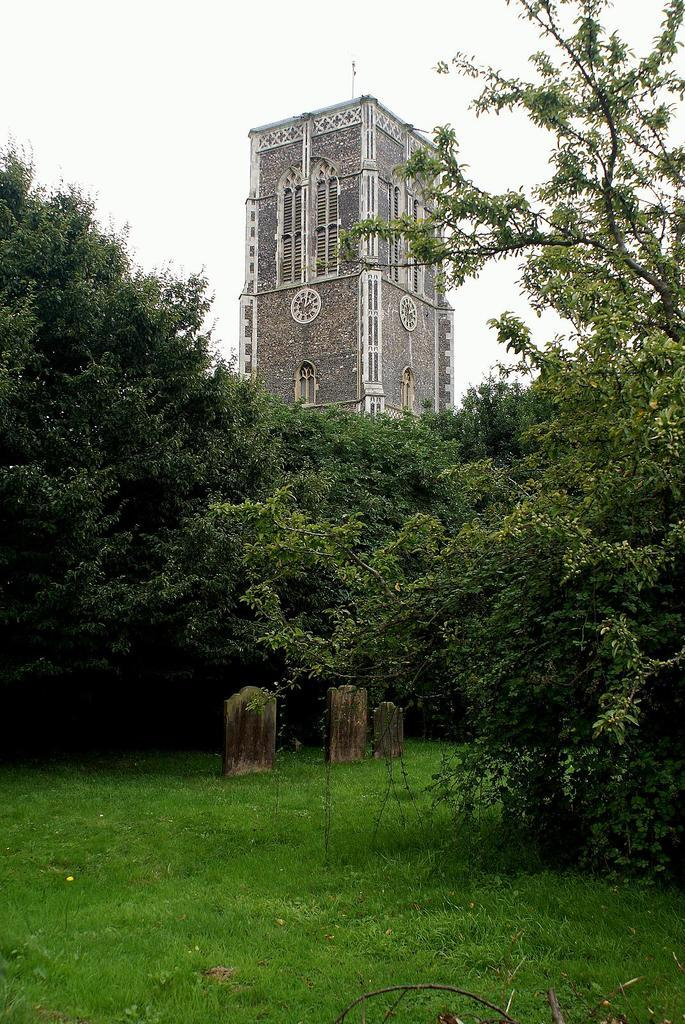What type of vegetation can be seen in the image? There is grass and trees in the image. What structures are visible in the background of the image? There is a building in the background of the image. What part of the natural environment is visible in the image? The sky is visible in the background of the image. What scent can be detected from the trees in the image? There is no information about the scent of the trees in the image, as we cannot detect scents through visuals. 